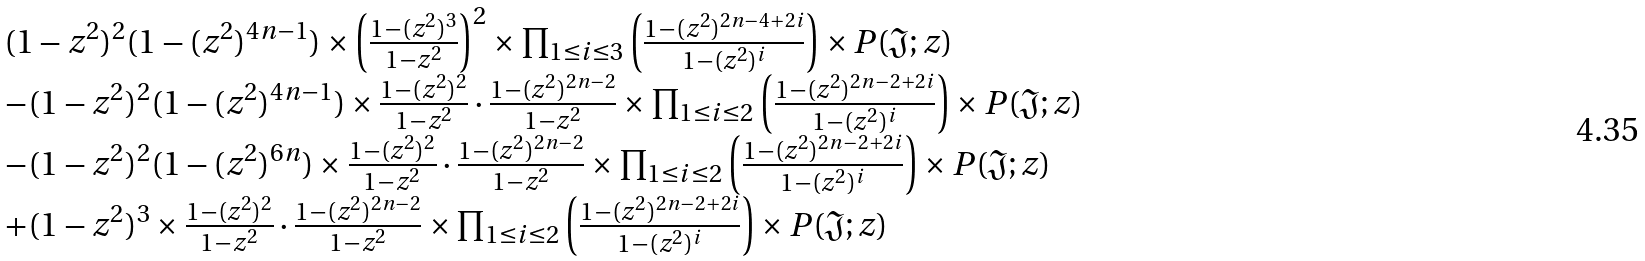Convert formula to latex. <formula><loc_0><loc_0><loc_500><loc_500>\begin{array} { l l l } ( 1 - z ^ { 2 } ) ^ { 2 } ( 1 - ( z ^ { 2 } ) ^ { 4 n - 1 } ) \times \left ( { \frac { 1 - ( z ^ { 2 } ) ^ { 3 } } { 1 - z ^ { 2 } } } \right ) ^ { 2 } \times \prod _ { 1 \leq i \leq 3 } \left ( { \frac { 1 - ( z ^ { 2 } ) ^ { 2 n - 4 + 2 i } } { 1 - ( z ^ { 2 } ) ^ { i } } } \right ) \times P ( \mathfrak J ; z ) & & \\ - ( 1 - z ^ { 2 } ) ^ { 2 } ( 1 - ( z ^ { 2 } ) ^ { 4 n - 1 } ) \times { \frac { 1 - ( z ^ { 2 } ) ^ { 2 } } { 1 - z ^ { 2 } } \cdot \frac { 1 - ( z ^ { 2 } ) ^ { 2 n - 2 } } { 1 - z ^ { 2 } } } \times \prod _ { 1 \leq i \leq 2 } \left ( { \frac { 1 - ( z ^ { 2 } ) ^ { 2 n - 2 + 2 i } } { 1 - ( z ^ { 2 } ) ^ { i } } } \right ) \times P ( \mathfrak J ; z ) & & \\ - ( 1 - z ^ { 2 } ) ^ { 2 } ( 1 - ( z ^ { 2 } ) ^ { 6 n } ) \times { \frac { 1 - ( z ^ { 2 } ) ^ { 2 } } { 1 - z ^ { 2 } } \cdot \frac { 1 - ( z ^ { 2 } ) ^ { 2 n - 2 } } { 1 - z ^ { 2 } } } \times \prod _ { 1 \leq i \leq 2 } \left ( { \frac { 1 - ( z ^ { 2 } ) ^ { 2 n - 2 + 2 i } } { 1 - ( z ^ { 2 } ) ^ { i } } } \right ) \times P ( \mathfrak J ; z ) & & \\ + ( 1 - z ^ { 2 } ) ^ { 3 } \times { \frac { 1 - ( z ^ { 2 } ) ^ { 2 } } { 1 - z ^ { 2 } } \cdot \frac { 1 - ( z ^ { 2 } ) ^ { 2 n - 2 } } { 1 - z ^ { 2 } } } \times \prod _ { 1 \leq i \leq 2 } \left ( { \frac { 1 - ( z ^ { 2 } ) ^ { 2 n - 2 + 2 i } } { 1 - ( z ^ { 2 } ) ^ { i } } } \right ) \times P ( \mathfrak J ; z ) & & \end{array}</formula> 